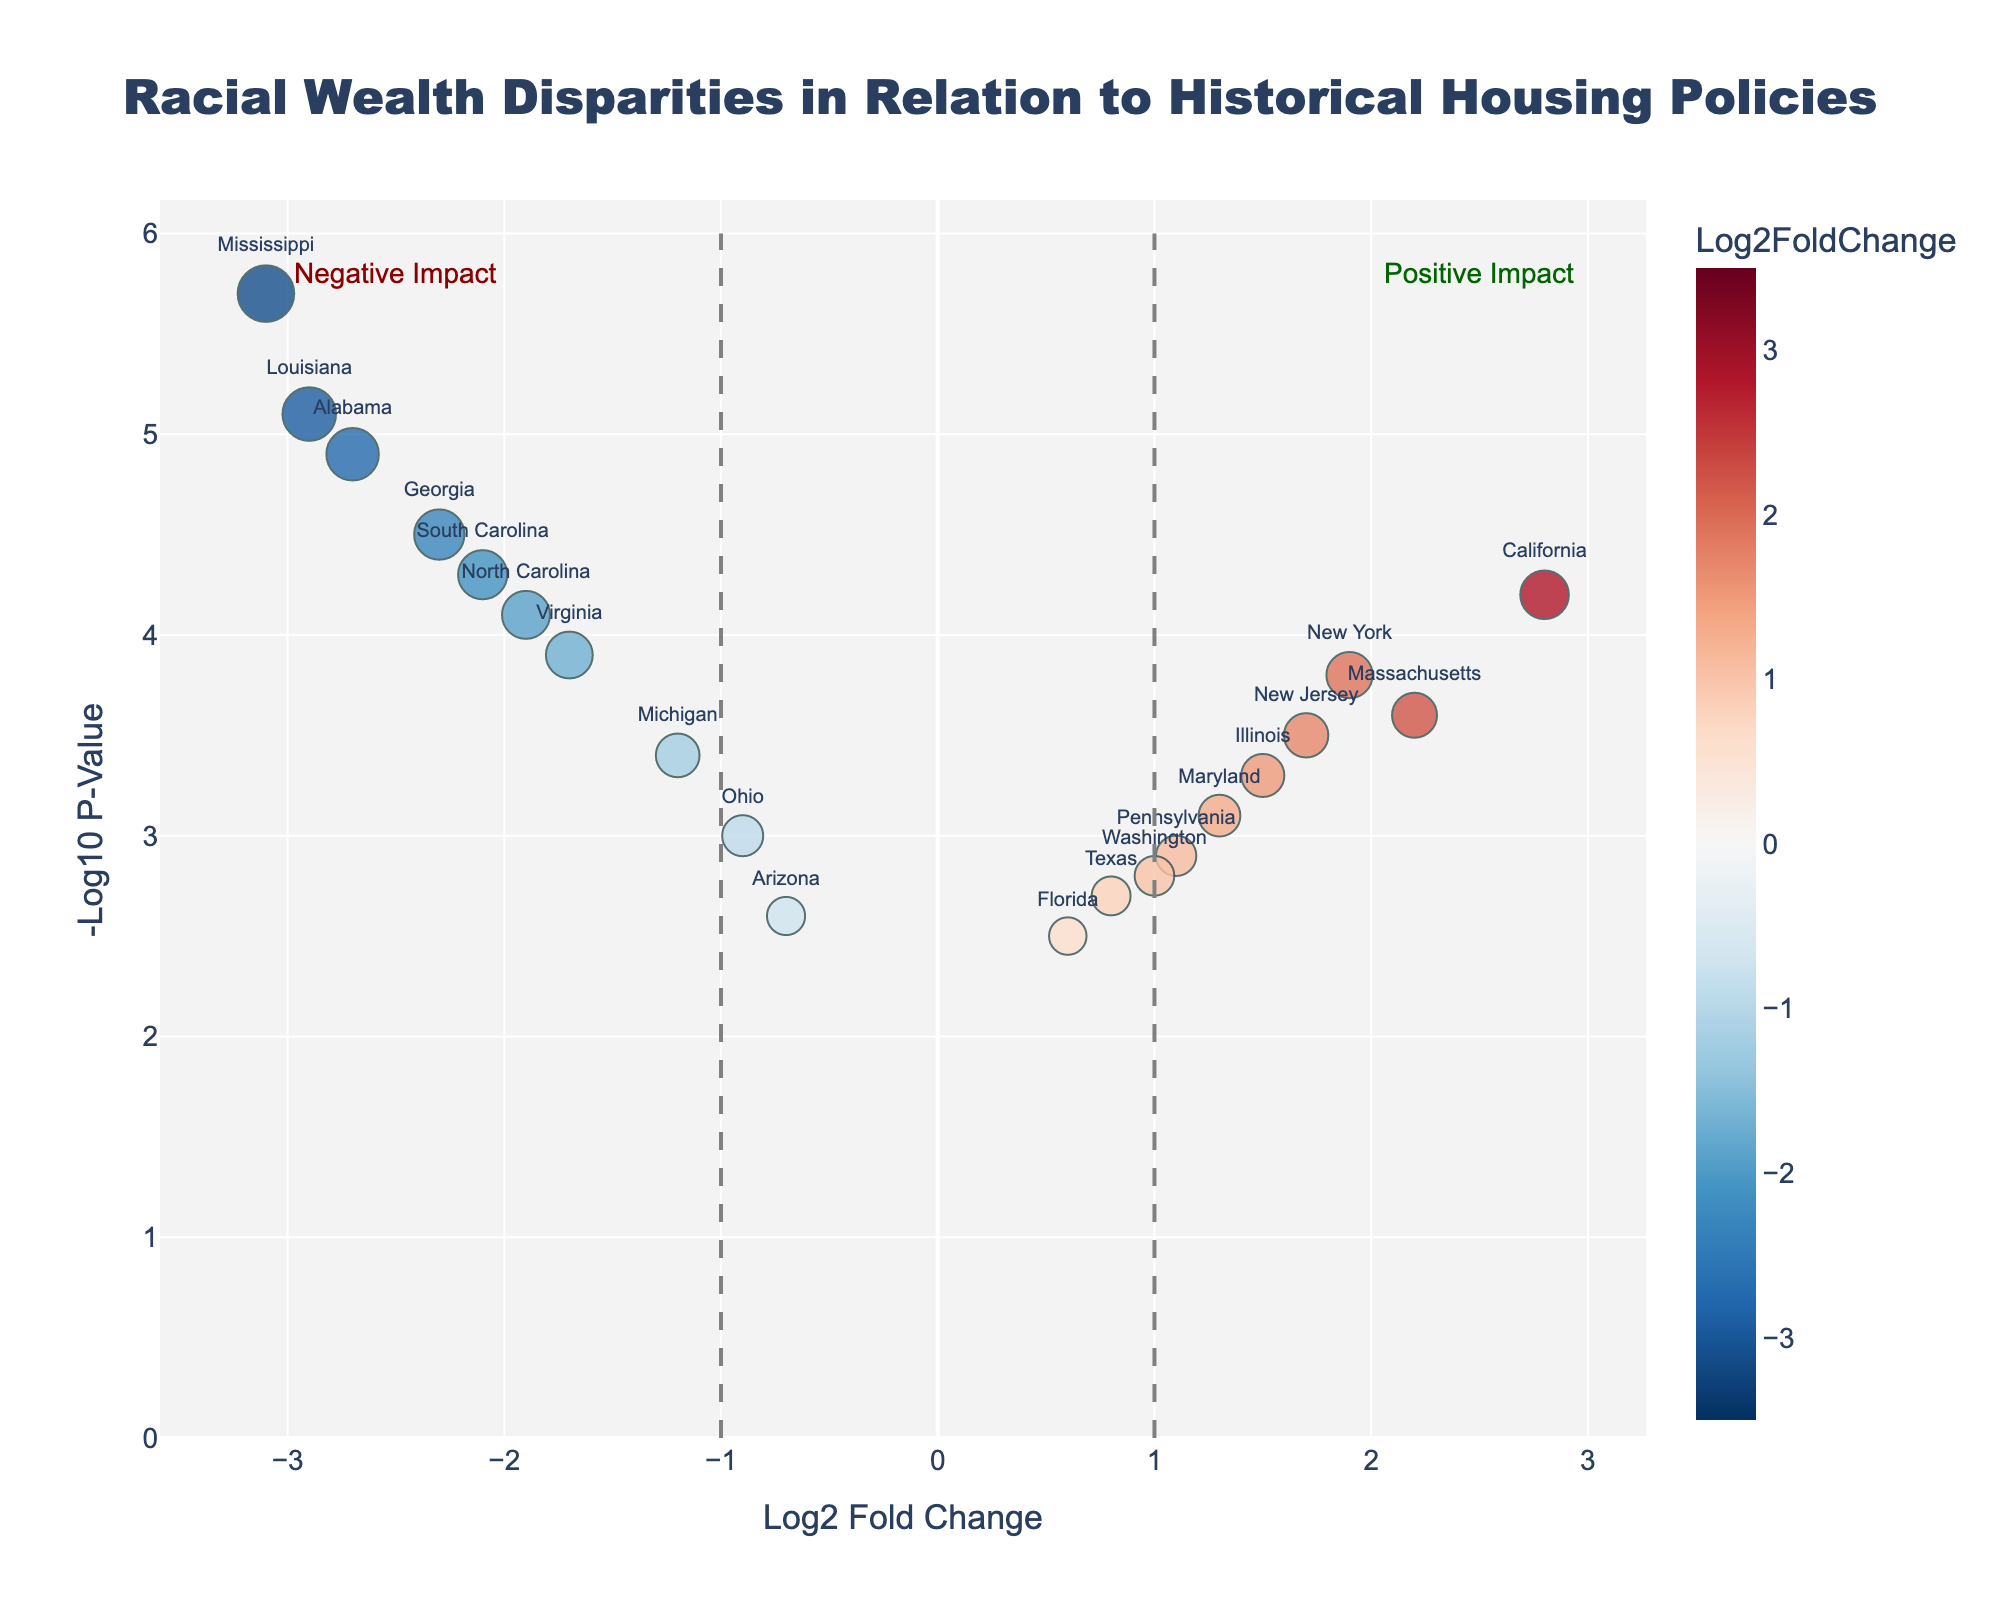How many states show a negative Log2 Fold Change? Count the number of states with a Log2 Fold Change value less than 0.
Answer: 10 What's the title of the volcano plot? The title is indicated at the top of the plot.
Answer: Racial Wealth Disparities in Relation to Historical Housing Policies Which state has the highest Negative Log10 P-Value? Look for the state that is positioned the highest on the y-axis.
Answer: Mississippi What is the Log2 Fold Change and Negative Log10 P-Value for California? Locate California on the plot and read its x and y values.
Answer: 2.8, 4.2 Identify a state with both a positive Log2 Fold Change and a Negative Log10 P-Value above 3.5? Look for states in the top-right quadrant with values above 3.5 on the y-axis and above 0 on the x-axis.
Answer: California, New York, Massachusetts, New Jersey How many states have a Negative Log10 P-Value greater than 4? Count the number of states positioned higher than 4 on the y-axis.
Answer: 8 Which states have a Log2 Fold Change between 1.5 and 2.5? Count the states that fall within this range on the x-axis.
Answer: New York, Massachusetts, New Jersey, Illinois Compare the Log2 Fold Change of Mississippi and Alabama. Which is more negative? Compare the x-axis values of Mississippi and Alabama and determine which value is smaller.
Answer: Mississippi What is the trend indicated by the dashed lines at x=-1 and x=1? The dashed lines represent boundaries for significant positive and negative impacts. The left part indicates a negative impact, and the right part indicates a positive impact.
Answer: Negative Impact (left), Positive Impact (right) Which state has the smallest Log2 Fold Change with a Negative Log10 P-Value above 4? Look for the state with the smallest x-axis value (most negative Log2 Fold Change) above the y-axis value of 4.
Answer: Mississippi 